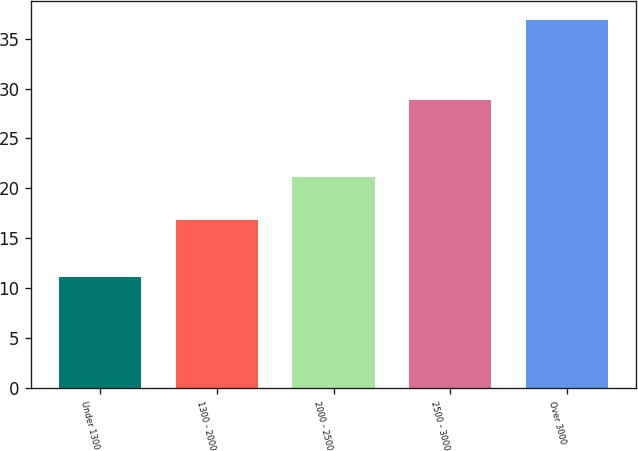Convert chart. <chart><loc_0><loc_0><loc_500><loc_500><bar_chart><fcel>Under 1300<fcel>1300 - 2000<fcel>2000 - 2500<fcel>2500 - 3000<fcel>Over 3000<nl><fcel>11.1<fcel>16.88<fcel>21.15<fcel>28.9<fcel>36.88<nl></chart> 